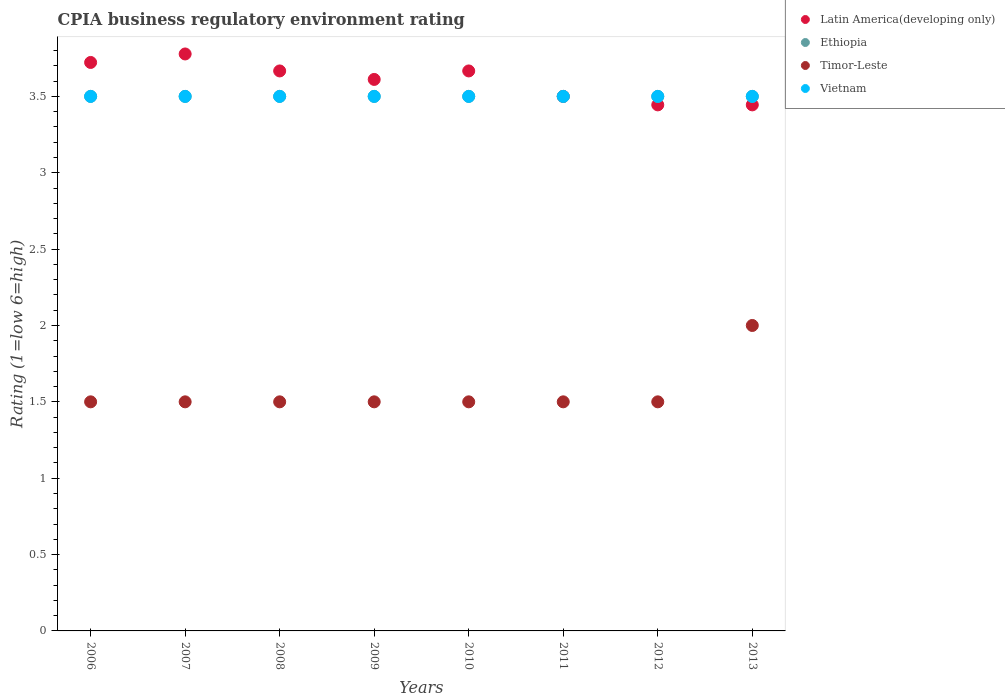Across all years, what is the maximum CPIA rating in Vietnam?
Offer a very short reply. 3.5. In which year was the CPIA rating in Vietnam maximum?
Make the answer very short. 2006. What is the total CPIA rating in Ethiopia in the graph?
Ensure brevity in your answer.  28. What is the difference between the CPIA rating in Timor-Leste in 2009 and that in 2010?
Give a very brief answer. 0. What is the difference between the CPIA rating in Latin America(developing only) in 2011 and the CPIA rating in Ethiopia in 2010?
Provide a short and direct response. 0. What is the average CPIA rating in Timor-Leste per year?
Make the answer very short. 1.56. In the year 2006, what is the difference between the CPIA rating in Timor-Leste and CPIA rating in Ethiopia?
Your response must be concise. -2. In how many years, is the CPIA rating in Timor-Leste greater than 3.3?
Your answer should be compact. 0. What is the ratio of the CPIA rating in Latin America(developing only) in 2009 to that in 2012?
Ensure brevity in your answer.  1.05. Is the difference between the CPIA rating in Timor-Leste in 2007 and 2010 greater than the difference between the CPIA rating in Ethiopia in 2007 and 2010?
Your answer should be compact. No. Is it the case that in every year, the sum of the CPIA rating in Latin America(developing only) and CPIA rating in Timor-Leste  is greater than the CPIA rating in Vietnam?
Provide a short and direct response. Yes. Is the CPIA rating in Latin America(developing only) strictly less than the CPIA rating in Timor-Leste over the years?
Your response must be concise. No. How many years are there in the graph?
Keep it short and to the point. 8. What is the difference between two consecutive major ticks on the Y-axis?
Your answer should be compact. 0.5. Does the graph contain any zero values?
Offer a very short reply. No. Does the graph contain grids?
Make the answer very short. No. How are the legend labels stacked?
Ensure brevity in your answer.  Vertical. What is the title of the graph?
Offer a very short reply. CPIA business regulatory environment rating. Does "Germany" appear as one of the legend labels in the graph?
Offer a very short reply. No. What is the label or title of the X-axis?
Make the answer very short. Years. What is the label or title of the Y-axis?
Your answer should be compact. Rating (1=low 6=high). What is the Rating (1=low 6=high) in Latin America(developing only) in 2006?
Your answer should be compact. 3.72. What is the Rating (1=low 6=high) of Vietnam in 2006?
Your answer should be compact. 3.5. What is the Rating (1=low 6=high) in Latin America(developing only) in 2007?
Keep it short and to the point. 3.78. What is the Rating (1=low 6=high) in Ethiopia in 2007?
Your response must be concise. 3.5. What is the Rating (1=low 6=high) of Timor-Leste in 2007?
Your answer should be compact. 1.5. What is the Rating (1=low 6=high) in Latin America(developing only) in 2008?
Your response must be concise. 3.67. What is the Rating (1=low 6=high) of Ethiopia in 2008?
Make the answer very short. 3.5. What is the Rating (1=low 6=high) of Latin America(developing only) in 2009?
Your answer should be compact. 3.61. What is the Rating (1=low 6=high) of Ethiopia in 2009?
Your response must be concise. 3.5. What is the Rating (1=low 6=high) of Vietnam in 2009?
Keep it short and to the point. 3.5. What is the Rating (1=low 6=high) of Latin America(developing only) in 2010?
Your answer should be compact. 3.67. What is the Rating (1=low 6=high) in Ethiopia in 2010?
Offer a terse response. 3.5. What is the Rating (1=low 6=high) of Timor-Leste in 2010?
Make the answer very short. 1.5. What is the Rating (1=low 6=high) in Vietnam in 2010?
Your answer should be very brief. 3.5. What is the Rating (1=low 6=high) of Ethiopia in 2011?
Your response must be concise. 3.5. What is the Rating (1=low 6=high) of Latin America(developing only) in 2012?
Your answer should be very brief. 3.44. What is the Rating (1=low 6=high) in Ethiopia in 2012?
Your answer should be very brief. 3.5. What is the Rating (1=low 6=high) in Vietnam in 2012?
Your answer should be compact. 3.5. What is the Rating (1=low 6=high) in Latin America(developing only) in 2013?
Provide a succinct answer. 3.44. What is the Rating (1=low 6=high) of Timor-Leste in 2013?
Give a very brief answer. 2. What is the Rating (1=low 6=high) of Vietnam in 2013?
Your response must be concise. 3.5. Across all years, what is the maximum Rating (1=low 6=high) in Latin America(developing only)?
Give a very brief answer. 3.78. Across all years, what is the maximum Rating (1=low 6=high) of Timor-Leste?
Ensure brevity in your answer.  2. Across all years, what is the maximum Rating (1=low 6=high) of Vietnam?
Offer a terse response. 3.5. Across all years, what is the minimum Rating (1=low 6=high) in Latin America(developing only)?
Offer a very short reply. 3.44. Across all years, what is the minimum Rating (1=low 6=high) of Ethiopia?
Ensure brevity in your answer.  3.5. Across all years, what is the minimum Rating (1=low 6=high) of Timor-Leste?
Offer a terse response. 1.5. What is the total Rating (1=low 6=high) of Latin America(developing only) in the graph?
Your answer should be very brief. 28.83. What is the total Rating (1=low 6=high) of Ethiopia in the graph?
Provide a short and direct response. 28. What is the difference between the Rating (1=low 6=high) of Latin America(developing only) in 2006 and that in 2007?
Give a very brief answer. -0.06. What is the difference between the Rating (1=low 6=high) of Latin America(developing only) in 2006 and that in 2008?
Keep it short and to the point. 0.06. What is the difference between the Rating (1=low 6=high) of Ethiopia in 2006 and that in 2008?
Your answer should be compact. 0. What is the difference between the Rating (1=low 6=high) of Vietnam in 2006 and that in 2008?
Give a very brief answer. 0. What is the difference between the Rating (1=low 6=high) in Vietnam in 2006 and that in 2009?
Your response must be concise. 0. What is the difference between the Rating (1=low 6=high) in Latin America(developing only) in 2006 and that in 2010?
Offer a very short reply. 0.06. What is the difference between the Rating (1=low 6=high) in Ethiopia in 2006 and that in 2010?
Your response must be concise. 0. What is the difference between the Rating (1=low 6=high) of Timor-Leste in 2006 and that in 2010?
Make the answer very short. 0. What is the difference between the Rating (1=low 6=high) in Latin America(developing only) in 2006 and that in 2011?
Make the answer very short. 0.22. What is the difference between the Rating (1=low 6=high) in Vietnam in 2006 and that in 2011?
Offer a terse response. 0. What is the difference between the Rating (1=low 6=high) of Latin America(developing only) in 2006 and that in 2012?
Ensure brevity in your answer.  0.28. What is the difference between the Rating (1=low 6=high) in Ethiopia in 2006 and that in 2012?
Make the answer very short. 0. What is the difference between the Rating (1=low 6=high) of Vietnam in 2006 and that in 2012?
Make the answer very short. 0. What is the difference between the Rating (1=low 6=high) in Latin America(developing only) in 2006 and that in 2013?
Your answer should be compact. 0.28. What is the difference between the Rating (1=low 6=high) of Vietnam in 2006 and that in 2013?
Your answer should be compact. 0. What is the difference between the Rating (1=low 6=high) of Latin America(developing only) in 2007 and that in 2008?
Your answer should be very brief. 0.11. What is the difference between the Rating (1=low 6=high) in Timor-Leste in 2007 and that in 2008?
Keep it short and to the point. 0. What is the difference between the Rating (1=low 6=high) in Vietnam in 2007 and that in 2008?
Give a very brief answer. 0. What is the difference between the Rating (1=low 6=high) in Latin America(developing only) in 2007 and that in 2009?
Provide a succinct answer. 0.17. What is the difference between the Rating (1=low 6=high) in Ethiopia in 2007 and that in 2009?
Your response must be concise. 0. What is the difference between the Rating (1=low 6=high) of Timor-Leste in 2007 and that in 2009?
Make the answer very short. 0. What is the difference between the Rating (1=low 6=high) of Timor-Leste in 2007 and that in 2010?
Provide a succinct answer. 0. What is the difference between the Rating (1=low 6=high) in Vietnam in 2007 and that in 2010?
Provide a short and direct response. 0. What is the difference between the Rating (1=low 6=high) in Latin America(developing only) in 2007 and that in 2011?
Your answer should be very brief. 0.28. What is the difference between the Rating (1=low 6=high) in Timor-Leste in 2007 and that in 2011?
Offer a terse response. 0. What is the difference between the Rating (1=low 6=high) of Vietnam in 2007 and that in 2011?
Your response must be concise. 0. What is the difference between the Rating (1=low 6=high) in Latin America(developing only) in 2007 and that in 2012?
Make the answer very short. 0.33. What is the difference between the Rating (1=low 6=high) of Timor-Leste in 2007 and that in 2013?
Ensure brevity in your answer.  -0.5. What is the difference between the Rating (1=low 6=high) of Latin America(developing only) in 2008 and that in 2009?
Offer a very short reply. 0.06. What is the difference between the Rating (1=low 6=high) of Vietnam in 2008 and that in 2009?
Your answer should be very brief. 0. What is the difference between the Rating (1=low 6=high) of Timor-Leste in 2008 and that in 2010?
Keep it short and to the point. 0. What is the difference between the Rating (1=low 6=high) of Vietnam in 2008 and that in 2010?
Your response must be concise. 0. What is the difference between the Rating (1=low 6=high) of Timor-Leste in 2008 and that in 2011?
Keep it short and to the point. 0. What is the difference between the Rating (1=low 6=high) of Latin America(developing only) in 2008 and that in 2012?
Your answer should be compact. 0.22. What is the difference between the Rating (1=low 6=high) of Timor-Leste in 2008 and that in 2012?
Make the answer very short. 0. What is the difference between the Rating (1=low 6=high) of Latin America(developing only) in 2008 and that in 2013?
Your answer should be compact. 0.22. What is the difference between the Rating (1=low 6=high) in Ethiopia in 2008 and that in 2013?
Your answer should be compact. 0. What is the difference between the Rating (1=low 6=high) of Vietnam in 2008 and that in 2013?
Your answer should be compact. 0. What is the difference between the Rating (1=low 6=high) in Latin America(developing only) in 2009 and that in 2010?
Provide a short and direct response. -0.06. What is the difference between the Rating (1=low 6=high) of Ethiopia in 2009 and that in 2010?
Your response must be concise. 0. What is the difference between the Rating (1=low 6=high) in Timor-Leste in 2009 and that in 2010?
Offer a very short reply. 0. What is the difference between the Rating (1=low 6=high) in Latin America(developing only) in 2009 and that in 2011?
Keep it short and to the point. 0.11. What is the difference between the Rating (1=low 6=high) in Vietnam in 2009 and that in 2011?
Ensure brevity in your answer.  0. What is the difference between the Rating (1=low 6=high) in Latin America(developing only) in 2009 and that in 2012?
Offer a terse response. 0.17. What is the difference between the Rating (1=low 6=high) of Ethiopia in 2009 and that in 2012?
Provide a succinct answer. 0. What is the difference between the Rating (1=low 6=high) of Timor-Leste in 2009 and that in 2012?
Your response must be concise. 0. What is the difference between the Rating (1=low 6=high) of Ethiopia in 2009 and that in 2013?
Provide a succinct answer. 0. What is the difference between the Rating (1=low 6=high) of Timor-Leste in 2009 and that in 2013?
Offer a terse response. -0.5. What is the difference between the Rating (1=low 6=high) of Vietnam in 2009 and that in 2013?
Your answer should be compact. 0. What is the difference between the Rating (1=low 6=high) in Ethiopia in 2010 and that in 2011?
Provide a succinct answer. 0. What is the difference between the Rating (1=low 6=high) of Latin America(developing only) in 2010 and that in 2012?
Your answer should be very brief. 0.22. What is the difference between the Rating (1=low 6=high) in Ethiopia in 2010 and that in 2012?
Your response must be concise. 0. What is the difference between the Rating (1=low 6=high) of Latin America(developing only) in 2010 and that in 2013?
Give a very brief answer. 0.22. What is the difference between the Rating (1=low 6=high) in Ethiopia in 2010 and that in 2013?
Ensure brevity in your answer.  0. What is the difference between the Rating (1=low 6=high) in Timor-Leste in 2010 and that in 2013?
Make the answer very short. -0.5. What is the difference between the Rating (1=low 6=high) in Latin America(developing only) in 2011 and that in 2012?
Your response must be concise. 0.06. What is the difference between the Rating (1=low 6=high) of Ethiopia in 2011 and that in 2012?
Give a very brief answer. 0. What is the difference between the Rating (1=low 6=high) in Timor-Leste in 2011 and that in 2012?
Keep it short and to the point. 0. What is the difference between the Rating (1=low 6=high) in Latin America(developing only) in 2011 and that in 2013?
Keep it short and to the point. 0.06. What is the difference between the Rating (1=low 6=high) of Latin America(developing only) in 2012 and that in 2013?
Your answer should be compact. 0. What is the difference between the Rating (1=low 6=high) of Timor-Leste in 2012 and that in 2013?
Your answer should be compact. -0.5. What is the difference between the Rating (1=low 6=high) in Latin America(developing only) in 2006 and the Rating (1=low 6=high) in Ethiopia in 2007?
Ensure brevity in your answer.  0.22. What is the difference between the Rating (1=low 6=high) in Latin America(developing only) in 2006 and the Rating (1=low 6=high) in Timor-Leste in 2007?
Ensure brevity in your answer.  2.22. What is the difference between the Rating (1=low 6=high) of Latin America(developing only) in 2006 and the Rating (1=low 6=high) of Vietnam in 2007?
Make the answer very short. 0.22. What is the difference between the Rating (1=low 6=high) in Ethiopia in 2006 and the Rating (1=low 6=high) in Vietnam in 2007?
Your response must be concise. 0. What is the difference between the Rating (1=low 6=high) of Latin America(developing only) in 2006 and the Rating (1=low 6=high) of Ethiopia in 2008?
Provide a succinct answer. 0.22. What is the difference between the Rating (1=low 6=high) of Latin America(developing only) in 2006 and the Rating (1=low 6=high) of Timor-Leste in 2008?
Give a very brief answer. 2.22. What is the difference between the Rating (1=low 6=high) of Latin America(developing only) in 2006 and the Rating (1=low 6=high) of Vietnam in 2008?
Your answer should be very brief. 0.22. What is the difference between the Rating (1=low 6=high) of Ethiopia in 2006 and the Rating (1=low 6=high) of Timor-Leste in 2008?
Keep it short and to the point. 2. What is the difference between the Rating (1=low 6=high) in Ethiopia in 2006 and the Rating (1=low 6=high) in Vietnam in 2008?
Your answer should be very brief. 0. What is the difference between the Rating (1=low 6=high) of Latin America(developing only) in 2006 and the Rating (1=low 6=high) of Ethiopia in 2009?
Your answer should be very brief. 0.22. What is the difference between the Rating (1=low 6=high) in Latin America(developing only) in 2006 and the Rating (1=low 6=high) in Timor-Leste in 2009?
Keep it short and to the point. 2.22. What is the difference between the Rating (1=low 6=high) of Latin America(developing only) in 2006 and the Rating (1=low 6=high) of Vietnam in 2009?
Ensure brevity in your answer.  0.22. What is the difference between the Rating (1=low 6=high) in Latin America(developing only) in 2006 and the Rating (1=low 6=high) in Ethiopia in 2010?
Give a very brief answer. 0.22. What is the difference between the Rating (1=low 6=high) in Latin America(developing only) in 2006 and the Rating (1=low 6=high) in Timor-Leste in 2010?
Ensure brevity in your answer.  2.22. What is the difference between the Rating (1=low 6=high) in Latin America(developing only) in 2006 and the Rating (1=low 6=high) in Vietnam in 2010?
Give a very brief answer. 0.22. What is the difference between the Rating (1=low 6=high) in Timor-Leste in 2006 and the Rating (1=low 6=high) in Vietnam in 2010?
Offer a terse response. -2. What is the difference between the Rating (1=low 6=high) in Latin America(developing only) in 2006 and the Rating (1=low 6=high) in Ethiopia in 2011?
Keep it short and to the point. 0.22. What is the difference between the Rating (1=low 6=high) of Latin America(developing only) in 2006 and the Rating (1=low 6=high) of Timor-Leste in 2011?
Your answer should be very brief. 2.22. What is the difference between the Rating (1=low 6=high) of Latin America(developing only) in 2006 and the Rating (1=low 6=high) of Vietnam in 2011?
Keep it short and to the point. 0.22. What is the difference between the Rating (1=low 6=high) of Ethiopia in 2006 and the Rating (1=low 6=high) of Timor-Leste in 2011?
Offer a terse response. 2. What is the difference between the Rating (1=low 6=high) of Timor-Leste in 2006 and the Rating (1=low 6=high) of Vietnam in 2011?
Make the answer very short. -2. What is the difference between the Rating (1=low 6=high) in Latin America(developing only) in 2006 and the Rating (1=low 6=high) in Ethiopia in 2012?
Provide a succinct answer. 0.22. What is the difference between the Rating (1=low 6=high) in Latin America(developing only) in 2006 and the Rating (1=low 6=high) in Timor-Leste in 2012?
Provide a short and direct response. 2.22. What is the difference between the Rating (1=low 6=high) of Latin America(developing only) in 2006 and the Rating (1=low 6=high) of Vietnam in 2012?
Make the answer very short. 0.22. What is the difference between the Rating (1=low 6=high) in Ethiopia in 2006 and the Rating (1=low 6=high) in Vietnam in 2012?
Your response must be concise. 0. What is the difference between the Rating (1=low 6=high) of Latin America(developing only) in 2006 and the Rating (1=low 6=high) of Ethiopia in 2013?
Ensure brevity in your answer.  0.22. What is the difference between the Rating (1=low 6=high) in Latin America(developing only) in 2006 and the Rating (1=low 6=high) in Timor-Leste in 2013?
Your answer should be very brief. 1.72. What is the difference between the Rating (1=low 6=high) in Latin America(developing only) in 2006 and the Rating (1=low 6=high) in Vietnam in 2013?
Offer a terse response. 0.22. What is the difference between the Rating (1=low 6=high) of Ethiopia in 2006 and the Rating (1=low 6=high) of Vietnam in 2013?
Offer a terse response. 0. What is the difference between the Rating (1=low 6=high) in Timor-Leste in 2006 and the Rating (1=low 6=high) in Vietnam in 2013?
Give a very brief answer. -2. What is the difference between the Rating (1=low 6=high) in Latin America(developing only) in 2007 and the Rating (1=low 6=high) in Ethiopia in 2008?
Ensure brevity in your answer.  0.28. What is the difference between the Rating (1=low 6=high) in Latin America(developing only) in 2007 and the Rating (1=low 6=high) in Timor-Leste in 2008?
Make the answer very short. 2.28. What is the difference between the Rating (1=low 6=high) in Latin America(developing only) in 2007 and the Rating (1=low 6=high) in Vietnam in 2008?
Your answer should be compact. 0.28. What is the difference between the Rating (1=low 6=high) of Ethiopia in 2007 and the Rating (1=low 6=high) of Vietnam in 2008?
Ensure brevity in your answer.  0. What is the difference between the Rating (1=low 6=high) of Latin America(developing only) in 2007 and the Rating (1=low 6=high) of Ethiopia in 2009?
Your answer should be compact. 0.28. What is the difference between the Rating (1=low 6=high) of Latin America(developing only) in 2007 and the Rating (1=low 6=high) of Timor-Leste in 2009?
Your response must be concise. 2.28. What is the difference between the Rating (1=low 6=high) of Latin America(developing only) in 2007 and the Rating (1=low 6=high) of Vietnam in 2009?
Offer a terse response. 0.28. What is the difference between the Rating (1=low 6=high) of Ethiopia in 2007 and the Rating (1=low 6=high) of Timor-Leste in 2009?
Give a very brief answer. 2. What is the difference between the Rating (1=low 6=high) of Ethiopia in 2007 and the Rating (1=low 6=high) of Vietnam in 2009?
Offer a very short reply. 0. What is the difference between the Rating (1=low 6=high) of Timor-Leste in 2007 and the Rating (1=low 6=high) of Vietnam in 2009?
Provide a succinct answer. -2. What is the difference between the Rating (1=low 6=high) of Latin America(developing only) in 2007 and the Rating (1=low 6=high) of Ethiopia in 2010?
Make the answer very short. 0.28. What is the difference between the Rating (1=low 6=high) of Latin America(developing only) in 2007 and the Rating (1=low 6=high) of Timor-Leste in 2010?
Offer a very short reply. 2.28. What is the difference between the Rating (1=low 6=high) of Latin America(developing only) in 2007 and the Rating (1=low 6=high) of Vietnam in 2010?
Keep it short and to the point. 0.28. What is the difference between the Rating (1=low 6=high) in Ethiopia in 2007 and the Rating (1=low 6=high) in Timor-Leste in 2010?
Offer a very short reply. 2. What is the difference between the Rating (1=low 6=high) in Ethiopia in 2007 and the Rating (1=low 6=high) in Vietnam in 2010?
Your answer should be very brief. 0. What is the difference between the Rating (1=low 6=high) of Latin America(developing only) in 2007 and the Rating (1=low 6=high) of Ethiopia in 2011?
Your response must be concise. 0.28. What is the difference between the Rating (1=low 6=high) of Latin America(developing only) in 2007 and the Rating (1=low 6=high) of Timor-Leste in 2011?
Ensure brevity in your answer.  2.28. What is the difference between the Rating (1=low 6=high) of Latin America(developing only) in 2007 and the Rating (1=low 6=high) of Vietnam in 2011?
Your answer should be compact. 0.28. What is the difference between the Rating (1=low 6=high) of Ethiopia in 2007 and the Rating (1=low 6=high) of Vietnam in 2011?
Keep it short and to the point. 0. What is the difference between the Rating (1=low 6=high) of Timor-Leste in 2007 and the Rating (1=low 6=high) of Vietnam in 2011?
Offer a terse response. -2. What is the difference between the Rating (1=low 6=high) of Latin America(developing only) in 2007 and the Rating (1=low 6=high) of Ethiopia in 2012?
Offer a very short reply. 0.28. What is the difference between the Rating (1=low 6=high) in Latin America(developing only) in 2007 and the Rating (1=low 6=high) in Timor-Leste in 2012?
Ensure brevity in your answer.  2.28. What is the difference between the Rating (1=low 6=high) of Latin America(developing only) in 2007 and the Rating (1=low 6=high) of Vietnam in 2012?
Ensure brevity in your answer.  0.28. What is the difference between the Rating (1=low 6=high) of Ethiopia in 2007 and the Rating (1=low 6=high) of Timor-Leste in 2012?
Ensure brevity in your answer.  2. What is the difference between the Rating (1=low 6=high) in Ethiopia in 2007 and the Rating (1=low 6=high) in Vietnam in 2012?
Provide a short and direct response. 0. What is the difference between the Rating (1=low 6=high) in Timor-Leste in 2007 and the Rating (1=low 6=high) in Vietnam in 2012?
Give a very brief answer. -2. What is the difference between the Rating (1=low 6=high) in Latin America(developing only) in 2007 and the Rating (1=low 6=high) in Ethiopia in 2013?
Your answer should be very brief. 0.28. What is the difference between the Rating (1=low 6=high) of Latin America(developing only) in 2007 and the Rating (1=low 6=high) of Timor-Leste in 2013?
Keep it short and to the point. 1.78. What is the difference between the Rating (1=low 6=high) in Latin America(developing only) in 2007 and the Rating (1=low 6=high) in Vietnam in 2013?
Give a very brief answer. 0.28. What is the difference between the Rating (1=low 6=high) in Ethiopia in 2007 and the Rating (1=low 6=high) in Timor-Leste in 2013?
Provide a succinct answer. 1.5. What is the difference between the Rating (1=low 6=high) of Ethiopia in 2007 and the Rating (1=low 6=high) of Vietnam in 2013?
Your response must be concise. 0. What is the difference between the Rating (1=low 6=high) of Timor-Leste in 2007 and the Rating (1=low 6=high) of Vietnam in 2013?
Provide a succinct answer. -2. What is the difference between the Rating (1=low 6=high) in Latin America(developing only) in 2008 and the Rating (1=low 6=high) in Timor-Leste in 2009?
Give a very brief answer. 2.17. What is the difference between the Rating (1=low 6=high) of Ethiopia in 2008 and the Rating (1=low 6=high) of Timor-Leste in 2009?
Provide a short and direct response. 2. What is the difference between the Rating (1=low 6=high) in Latin America(developing only) in 2008 and the Rating (1=low 6=high) in Timor-Leste in 2010?
Offer a very short reply. 2.17. What is the difference between the Rating (1=low 6=high) in Latin America(developing only) in 2008 and the Rating (1=low 6=high) in Vietnam in 2010?
Give a very brief answer. 0.17. What is the difference between the Rating (1=low 6=high) of Latin America(developing only) in 2008 and the Rating (1=low 6=high) of Timor-Leste in 2011?
Give a very brief answer. 2.17. What is the difference between the Rating (1=low 6=high) of Ethiopia in 2008 and the Rating (1=low 6=high) of Timor-Leste in 2011?
Ensure brevity in your answer.  2. What is the difference between the Rating (1=low 6=high) in Timor-Leste in 2008 and the Rating (1=low 6=high) in Vietnam in 2011?
Ensure brevity in your answer.  -2. What is the difference between the Rating (1=low 6=high) of Latin America(developing only) in 2008 and the Rating (1=low 6=high) of Timor-Leste in 2012?
Your answer should be compact. 2.17. What is the difference between the Rating (1=low 6=high) of Ethiopia in 2008 and the Rating (1=low 6=high) of Vietnam in 2012?
Your answer should be very brief. 0. What is the difference between the Rating (1=low 6=high) in Ethiopia in 2008 and the Rating (1=low 6=high) in Timor-Leste in 2013?
Give a very brief answer. 1.5. What is the difference between the Rating (1=low 6=high) of Timor-Leste in 2008 and the Rating (1=low 6=high) of Vietnam in 2013?
Ensure brevity in your answer.  -2. What is the difference between the Rating (1=low 6=high) of Latin America(developing only) in 2009 and the Rating (1=low 6=high) of Timor-Leste in 2010?
Your answer should be very brief. 2.11. What is the difference between the Rating (1=low 6=high) in Timor-Leste in 2009 and the Rating (1=low 6=high) in Vietnam in 2010?
Offer a very short reply. -2. What is the difference between the Rating (1=low 6=high) in Latin America(developing only) in 2009 and the Rating (1=low 6=high) in Ethiopia in 2011?
Provide a succinct answer. 0.11. What is the difference between the Rating (1=low 6=high) in Latin America(developing only) in 2009 and the Rating (1=low 6=high) in Timor-Leste in 2011?
Offer a terse response. 2.11. What is the difference between the Rating (1=low 6=high) of Ethiopia in 2009 and the Rating (1=low 6=high) of Timor-Leste in 2011?
Your answer should be compact. 2. What is the difference between the Rating (1=low 6=high) of Ethiopia in 2009 and the Rating (1=low 6=high) of Vietnam in 2011?
Provide a short and direct response. 0. What is the difference between the Rating (1=low 6=high) in Timor-Leste in 2009 and the Rating (1=low 6=high) in Vietnam in 2011?
Ensure brevity in your answer.  -2. What is the difference between the Rating (1=low 6=high) of Latin America(developing only) in 2009 and the Rating (1=low 6=high) of Timor-Leste in 2012?
Your response must be concise. 2.11. What is the difference between the Rating (1=low 6=high) in Latin America(developing only) in 2009 and the Rating (1=low 6=high) in Vietnam in 2012?
Offer a terse response. 0.11. What is the difference between the Rating (1=low 6=high) of Ethiopia in 2009 and the Rating (1=low 6=high) of Vietnam in 2012?
Ensure brevity in your answer.  0. What is the difference between the Rating (1=low 6=high) of Latin America(developing only) in 2009 and the Rating (1=low 6=high) of Ethiopia in 2013?
Give a very brief answer. 0.11. What is the difference between the Rating (1=low 6=high) of Latin America(developing only) in 2009 and the Rating (1=low 6=high) of Timor-Leste in 2013?
Ensure brevity in your answer.  1.61. What is the difference between the Rating (1=low 6=high) in Latin America(developing only) in 2009 and the Rating (1=low 6=high) in Vietnam in 2013?
Provide a short and direct response. 0.11. What is the difference between the Rating (1=low 6=high) in Ethiopia in 2009 and the Rating (1=low 6=high) in Timor-Leste in 2013?
Your answer should be compact. 1.5. What is the difference between the Rating (1=low 6=high) in Ethiopia in 2009 and the Rating (1=low 6=high) in Vietnam in 2013?
Give a very brief answer. 0. What is the difference between the Rating (1=low 6=high) in Timor-Leste in 2009 and the Rating (1=low 6=high) in Vietnam in 2013?
Your answer should be very brief. -2. What is the difference between the Rating (1=low 6=high) of Latin America(developing only) in 2010 and the Rating (1=low 6=high) of Ethiopia in 2011?
Give a very brief answer. 0.17. What is the difference between the Rating (1=low 6=high) in Latin America(developing only) in 2010 and the Rating (1=low 6=high) in Timor-Leste in 2011?
Make the answer very short. 2.17. What is the difference between the Rating (1=low 6=high) in Timor-Leste in 2010 and the Rating (1=low 6=high) in Vietnam in 2011?
Keep it short and to the point. -2. What is the difference between the Rating (1=low 6=high) in Latin America(developing only) in 2010 and the Rating (1=low 6=high) in Timor-Leste in 2012?
Offer a very short reply. 2.17. What is the difference between the Rating (1=low 6=high) in Latin America(developing only) in 2010 and the Rating (1=low 6=high) in Vietnam in 2012?
Provide a succinct answer. 0.17. What is the difference between the Rating (1=low 6=high) in Latin America(developing only) in 2010 and the Rating (1=low 6=high) in Ethiopia in 2013?
Provide a succinct answer. 0.17. What is the difference between the Rating (1=low 6=high) of Latin America(developing only) in 2010 and the Rating (1=low 6=high) of Timor-Leste in 2013?
Offer a very short reply. 1.67. What is the difference between the Rating (1=low 6=high) in Latin America(developing only) in 2010 and the Rating (1=low 6=high) in Vietnam in 2013?
Your response must be concise. 0.17. What is the difference between the Rating (1=low 6=high) in Ethiopia in 2010 and the Rating (1=low 6=high) in Timor-Leste in 2013?
Ensure brevity in your answer.  1.5. What is the difference between the Rating (1=low 6=high) in Ethiopia in 2010 and the Rating (1=low 6=high) in Vietnam in 2013?
Keep it short and to the point. 0. What is the difference between the Rating (1=low 6=high) in Timor-Leste in 2010 and the Rating (1=low 6=high) in Vietnam in 2013?
Make the answer very short. -2. What is the difference between the Rating (1=low 6=high) in Latin America(developing only) in 2011 and the Rating (1=low 6=high) in Ethiopia in 2012?
Your answer should be very brief. 0. What is the difference between the Rating (1=low 6=high) of Latin America(developing only) in 2011 and the Rating (1=low 6=high) of Timor-Leste in 2012?
Keep it short and to the point. 2. What is the difference between the Rating (1=low 6=high) in Latin America(developing only) in 2011 and the Rating (1=low 6=high) in Vietnam in 2012?
Keep it short and to the point. 0. What is the difference between the Rating (1=low 6=high) in Ethiopia in 2011 and the Rating (1=low 6=high) in Timor-Leste in 2012?
Give a very brief answer. 2. What is the difference between the Rating (1=low 6=high) of Ethiopia in 2011 and the Rating (1=low 6=high) of Vietnam in 2012?
Provide a short and direct response. 0. What is the difference between the Rating (1=low 6=high) of Timor-Leste in 2011 and the Rating (1=low 6=high) of Vietnam in 2012?
Give a very brief answer. -2. What is the difference between the Rating (1=low 6=high) of Latin America(developing only) in 2011 and the Rating (1=low 6=high) of Ethiopia in 2013?
Your answer should be very brief. 0. What is the difference between the Rating (1=low 6=high) of Ethiopia in 2011 and the Rating (1=low 6=high) of Timor-Leste in 2013?
Ensure brevity in your answer.  1.5. What is the difference between the Rating (1=low 6=high) of Latin America(developing only) in 2012 and the Rating (1=low 6=high) of Ethiopia in 2013?
Offer a terse response. -0.06. What is the difference between the Rating (1=low 6=high) of Latin America(developing only) in 2012 and the Rating (1=low 6=high) of Timor-Leste in 2013?
Your answer should be very brief. 1.44. What is the difference between the Rating (1=low 6=high) of Latin America(developing only) in 2012 and the Rating (1=low 6=high) of Vietnam in 2013?
Give a very brief answer. -0.06. What is the difference between the Rating (1=low 6=high) in Timor-Leste in 2012 and the Rating (1=low 6=high) in Vietnam in 2013?
Give a very brief answer. -2. What is the average Rating (1=low 6=high) in Latin America(developing only) per year?
Make the answer very short. 3.6. What is the average Rating (1=low 6=high) of Timor-Leste per year?
Keep it short and to the point. 1.56. In the year 2006, what is the difference between the Rating (1=low 6=high) of Latin America(developing only) and Rating (1=low 6=high) of Ethiopia?
Offer a terse response. 0.22. In the year 2006, what is the difference between the Rating (1=low 6=high) of Latin America(developing only) and Rating (1=low 6=high) of Timor-Leste?
Offer a terse response. 2.22. In the year 2006, what is the difference between the Rating (1=low 6=high) in Latin America(developing only) and Rating (1=low 6=high) in Vietnam?
Your answer should be compact. 0.22. In the year 2006, what is the difference between the Rating (1=low 6=high) of Ethiopia and Rating (1=low 6=high) of Vietnam?
Ensure brevity in your answer.  0. In the year 2006, what is the difference between the Rating (1=low 6=high) in Timor-Leste and Rating (1=low 6=high) in Vietnam?
Your answer should be very brief. -2. In the year 2007, what is the difference between the Rating (1=low 6=high) in Latin America(developing only) and Rating (1=low 6=high) in Ethiopia?
Provide a succinct answer. 0.28. In the year 2007, what is the difference between the Rating (1=low 6=high) of Latin America(developing only) and Rating (1=low 6=high) of Timor-Leste?
Your answer should be very brief. 2.28. In the year 2007, what is the difference between the Rating (1=low 6=high) of Latin America(developing only) and Rating (1=low 6=high) of Vietnam?
Keep it short and to the point. 0.28. In the year 2007, what is the difference between the Rating (1=low 6=high) of Ethiopia and Rating (1=low 6=high) of Timor-Leste?
Your response must be concise. 2. In the year 2007, what is the difference between the Rating (1=low 6=high) in Timor-Leste and Rating (1=low 6=high) in Vietnam?
Your answer should be compact. -2. In the year 2008, what is the difference between the Rating (1=low 6=high) of Latin America(developing only) and Rating (1=low 6=high) of Timor-Leste?
Give a very brief answer. 2.17. In the year 2008, what is the difference between the Rating (1=low 6=high) in Latin America(developing only) and Rating (1=low 6=high) in Vietnam?
Your response must be concise. 0.17. In the year 2008, what is the difference between the Rating (1=low 6=high) in Ethiopia and Rating (1=low 6=high) in Timor-Leste?
Give a very brief answer. 2. In the year 2008, what is the difference between the Rating (1=low 6=high) of Timor-Leste and Rating (1=low 6=high) of Vietnam?
Offer a very short reply. -2. In the year 2009, what is the difference between the Rating (1=low 6=high) in Latin America(developing only) and Rating (1=low 6=high) in Timor-Leste?
Make the answer very short. 2.11. In the year 2009, what is the difference between the Rating (1=low 6=high) in Ethiopia and Rating (1=low 6=high) in Vietnam?
Your answer should be compact. 0. In the year 2009, what is the difference between the Rating (1=low 6=high) in Timor-Leste and Rating (1=low 6=high) in Vietnam?
Provide a short and direct response. -2. In the year 2010, what is the difference between the Rating (1=low 6=high) in Latin America(developing only) and Rating (1=low 6=high) in Timor-Leste?
Your answer should be compact. 2.17. In the year 2010, what is the difference between the Rating (1=low 6=high) of Latin America(developing only) and Rating (1=low 6=high) of Vietnam?
Keep it short and to the point. 0.17. In the year 2010, what is the difference between the Rating (1=low 6=high) of Ethiopia and Rating (1=low 6=high) of Vietnam?
Your answer should be compact. 0. In the year 2011, what is the difference between the Rating (1=low 6=high) of Latin America(developing only) and Rating (1=low 6=high) of Ethiopia?
Make the answer very short. 0. In the year 2011, what is the difference between the Rating (1=low 6=high) in Latin America(developing only) and Rating (1=low 6=high) in Timor-Leste?
Ensure brevity in your answer.  2. In the year 2011, what is the difference between the Rating (1=low 6=high) in Latin America(developing only) and Rating (1=low 6=high) in Vietnam?
Ensure brevity in your answer.  0. In the year 2011, what is the difference between the Rating (1=low 6=high) in Ethiopia and Rating (1=low 6=high) in Timor-Leste?
Your response must be concise. 2. In the year 2011, what is the difference between the Rating (1=low 6=high) of Ethiopia and Rating (1=low 6=high) of Vietnam?
Your answer should be compact. 0. In the year 2011, what is the difference between the Rating (1=low 6=high) of Timor-Leste and Rating (1=low 6=high) of Vietnam?
Provide a succinct answer. -2. In the year 2012, what is the difference between the Rating (1=low 6=high) in Latin America(developing only) and Rating (1=low 6=high) in Ethiopia?
Your answer should be compact. -0.06. In the year 2012, what is the difference between the Rating (1=low 6=high) of Latin America(developing only) and Rating (1=low 6=high) of Timor-Leste?
Provide a succinct answer. 1.94. In the year 2012, what is the difference between the Rating (1=low 6=high) in Latin America(developing only) and Rating (1=low 6=high) in Vietnam?
Give a very brief answer. -0.06. In the year 2012, what is the difference between the Rating (1=low 6=high) of Ethiopia and Rating (1=low 6=high) of Timor-Leste?
Make the answer very short. 2. In the year 2012, what is the difference between the Rating (1=low 6=high) of Timor-Leste and Rating (1=low 6=high) of Vietnam?
Your answer should be compact. -2. In the year 2013, what is the difference between the Rating (1=low 6=high) of Latin America(developing only) and Rating (1=low 6=high) of Ethiopia?
Ensure brevity in your answer.  -0.06. In the year 2013, what is the difference between the Rating (1=low 6=high) in Latin America(developing only) and Rating (1=low 6=high) in Timor-Leste?
Keep it short and to the point. 1.44. In the year 2013, what is the difference between the Rating (1=low 6=high) in Latin America(developing only) and Rating (1=low 6=high) in Vietnam?
Give a very brief answer. -0.06. What is the ratio of the Rating (1=low 6=high) of Latin America(developing only) in 2006 to that in 2007?
Your answer should be very brief. 0.99. What is the ratio of the Rating (1=low 6=high) in Ethiopia in 2006 to that in 2007?
Make the answer very short. 1. What is the ratio of the Rating (1=low 6=high) of Timor-Leste in 2006 to that in 2007?
Provide a succinct answer. 1. What is the ratio of the Rating (1=low 6=high) of Latin America(developing only) in 2006 to that in 2008?
Ensure brevity in your answer.  1.02. What is the ratio of the Rating (1=low 6=high) in Latin America(developing only) in 2006 to that in 2009?
Offer a very short reply. 1.03. What is the ratio of the Rating (1=low 6=high) in Ethiopia in 2006 to that in 2009?
Offer a terse response. 1. What is the ratio of the Rating (1=low 6=high) of Latin America(developing only) in 2006 to that in 2010?
Offer a very short reply. 1.02. What is the ratio of the Rating (1=low 6=high) in Ethiopia in 2006 to that in 2010?
Provide a short and direct response. 1. What is the ratio of the Rating (1=low 6=high) in Vietnam in 2006 to that in 2010?
Provide a succinct answer. 1. What is the ratio of the Rating (1=low 6=high) in Latin America(developing only) in 2006 to that in 2011?
Offer a terse response. 1.06. What is the ratio of the Rating (1=low 6=high) in Timor-Leste in 2006 to that in 2011?
Your answer should be compact. 1. What is the ratio of the Rating (1=low 6=high) in Latin America(developing only) in 2006 to that in 2012?
Keep it short and to the point. 1.08. What is the ratio of the Rating (1=low 6=high) of Timor-Leste in 2006 to that in 2012?
Offer a very short reply. 1. What is the ratio of the Rating (1=low 6=high) of Latin America(developing only) in 2006 to that in 2013?
Your answer should be very brief. 1.08. What is the ratio of the Rating (1=low 6=high) in Ethiopia in 2006 to that in 2013?
Make the answer very short. 1. What is the ratio of the Rating (1=low 6=high) in Timor-Leste in 2006 to that in 2013?
Your answer should be very brief. 0.75. What is the ratio of the Rating (1=low 6=high) of Latin America(developing only) in 2007 to that in 2008?
Your answer should be very brief. 1.03. What is the ratio of the Rating (1=low 6=high) of Vietnam in 2007 to that in 2008?
Ensure brevity in your answer.  1. What is the ratio of the Rating (1=low 6=high) of Latin America(developing only) in 2007 to that in 2009?
Offer a terse response. 1.05. What is the ratio of the Rating (1=low 6=high) of Ethiopia in 2007 to that in 2009?
Offer a very short reply. 1. What is the ratio of the Rating (1=low 6=high) in Timor-Leste in 2007 to that in 2009?
Offer a terse response. 1. What is the ratio of the Rating (1=low 6=high) in Vietnam in 2007 to that in 2009?
Ensure brevity in your answer.  1. What is the ratio of the Rating (1=low 6=high) in Latin America(developing only) in 2007 to that in 2010?
Make the answer very short. 1.03. What is the ratio of the Rating (1=low 6=high) in Vietnam in 2007 to that in 2010?
Offer a terse response. 1. What is the ratio of the Rating (1=low 6=high) of Latin America(developing only) in 2007 to that in 2011?
Provide a short and direct response. 1.08. What is the ratio of the Rating (1=low 6=high) in Ethiopia in 2007 to that in 2011?
Provide a succinct answer. 1. What is the ratio of the Rating (1=low 6=high) of Timor-Leste in 2007 to that in 2011?
Your answer should be compact. 1. What is the ratio of the Rating (1=low 6=high) of Vietnam in 2007 to that in 2011?
Provide a short and direct response. 1. What is the ratio of the Rating (1=low 6=high) of Latin America(developing only) in 2007 to that in 2012?
Offer a very short reply. 1.1. What is the ratio of the Rating (1=low 6=high) in Ethiopia in 2007 to that in 2012?
Offer a very short reply. 1. What is the ratio of the Rating (1=low 6=high) of Timor-Leste in 2007 to that in 2012?
Your response must be concise. 1. What is the ratio of the Rating (1=low 6=high) in Vietnam in 2007 to that in 2012?
Your response must be concise. 1. What is the ratio of the Rating (1=low 6=high) in Latin America(developing only) in 2007 to that in 2013?
Provide a short and direct response. 1.1. What is the ratio of the Rating (1=low 6=high) of Ethiopia in 2007 to that in 2013?
Make the answer very short. 1. What is the ratio of the Rating (1=low 6=high) of Timor-Leste in 2007 to that in 2013?
Make the answer very short. 0.75. What is the ratio of the Rating (1=low 6=high) of Latin America(developing only) in 2008 to that in 2009?
Your answer should be compact. 1.02. What is the ratio of the Rating (1=low 6=high) of Ethiopia in 2008 to that in 2009?
Your answer should be very brief. 1. What is the ratio of the Rating (1=low 6=high) in Timor-Leste in 2008 to that in 2009?
Provide a succinct answer. 1. What is the ratio of the Rating (1=low 6=high) in Vietnam in 2008 to that in 2010?
Your answer should be compact. 1. What is the ratio of the Rating (1=low 6=high) in Latin America(developing only) in 2008 to that in 2011?
Make the answer very short. 1.05. What is the ratio of the Rating (1=low 6=high) of Ethiopia in 2008 to that in 2011?
Offer a very short reply. 1. What is the ratio of the Rating (1=low 6=high) in Vietnam in 2008 to that in 2011?
Your answer should be compact. 1. What is the ratio of the Rating (1=low 6=high) of Latin America(developing only) in 2008 to that in 2012?
Make the answer very short. 1.06. What is the ratio of the Rating (1=low 6=high) of Latin America(developing only) in 2008 to that in 2013?
Your response must be concise. 1.06. What is the ratio of the Rating (1=low 6=high) of Ethiopia in 2008 to that in 2013?
Ensure brevity in your answer.  1. What is the ratio of the Rating (1=low 6=high) in Latin America(developing only) in 2009 to that in 2010?
Ensure brevity in your answer.  0.98. What is the ratio of the Rating (1=low 6=high) of Timor-Leste in 2009 to that in 2010?
Make the answer very short. 1. What is the ratio of the Rating (1=low 6=high) in Vietnam in 2009 to that in 2010?
Offer a very short reply. 1. What is the ratio of the Rating (1=low 6=high) in Latin America(developing only) in 2009 to that in 2011?
Give a very brief answer. 1.03. What is the ratio of the Rating (1=low 6=high) in Ethiopia in 2009 to that in 2011?
Make the answer very short. 1. What is the ratio of the Rating (1=low 6=high) in Timor-Leste in 2009 to that in 2011?
Ensure brevity in your answer.  1. What is the ratio of the Rating (1=low 6=high) of Vietnam in 2009 to that in 2011?
Offer a terse response. 1. What is the ratio of the Rating (1=low 6=high) in Latin America(developing only) in 2009 to that in 2012?
Provide a succinct answer. 1.05. What is the ratio of the Rating (1=low 6=high) of Ethiopia in 2009 to that in 2012?
Provide a short and direct response. 1. What is the ratio of the Rating (1=low 6=high) of Vietnam in 2009 to that in 2012?
Provide a short and direct response. 1. What is the ratio of the Rating (1=low 6=high) in Latin America(developing only) in 2009 to that in 2013?
Make the answer very short. 1.05. What is the ratio of the Rating (1=low 6=high) of Timor-Leste in 2009 to that in 2013?
Provide a succinct answer. 0.75. What is the ratio of the Rating (1=low 6=high) in Vietnam in 2009 to that in 2013?
Give a very brief answer. 1. What is the ratio of the Rating (1=low 6=high) in Latin America(developing only) in 2010 to that in 2011?
Ensure brevity in your answer.  1.05. What is the ratio of the Rating (1=low 6=high) in Vietnam in 2010 to that in 2011?
Provide a succinct answer. 1. What is the ratio of the Rating (1=low 6=high) in Latin America(developing only) in 2010 to that in 2012?
Provide a short and direct response. 1.06. What is the ratio of the Rating (1=low 6=high) of Ethiopia in 2010 to that in 2012?
Ensure brevity in your answer.  1. What is the ratio of the Rating (1=low 6=high) of Timor-Leste in 2010 to that in 2012?
Keep it short and to the point. 1. What is the ratio of the Rating (1=low 6=high) of Latin America(developing only) in 2010 to that in 2013?
Keep it short and to the point. 1.06. What is the ratio of the Rating (1=low 6=high) in Latin America(developing only) in 2011 to that in 2012?
Your answer should be compact. 1.02. What is the ratio of the Rating (1=low 6=high) in Ethiopia in 2011 to that in 2012?
Your response must be concise. 1. What is the ratio of the Rating (1=low 6=high) of Timor-Leste in 2011 to that in 2012?
Provide a succinct answer. 1. What is the ratio of the Rating (1=low 6=high) of Latin America(developing only) in 2011 to that in 2013?
Keep it short and to the point. 1.02. What is the ratio of the Rating (1=low 6=high) in Timor-Leste in 2011 to that in 2013?
Keep it short and to the point. 0.75. What is the ratio of the Rating (1=low 6=high) in Latin America(developing only) in 2012 to that in 2013?
Provide a short and direct response. 1. What is the ratio of the Rating (1=low 6=high) in Timor-Leste in 2012 to that in 2013?
Your answer should be very brief. 0.75. What is the difference between the highest and the second highest Rating (1=low 6=high) in Latin America(developing only)?
Offer a very short reply. 0.06. What is the difference between the highest and the second highest Rating (1=low 6=high) in Timor-Leste?
Give a very brief answer. 0.5. What is the difference between the highest and the lowest Rating (1=low 6=high) in Timor-Leste?
Make the answer very short. 0.5. What is the difference between the highest and the lowest Rating (1=low 6=high) of Vietnam?
Offer a terse response. 0. 